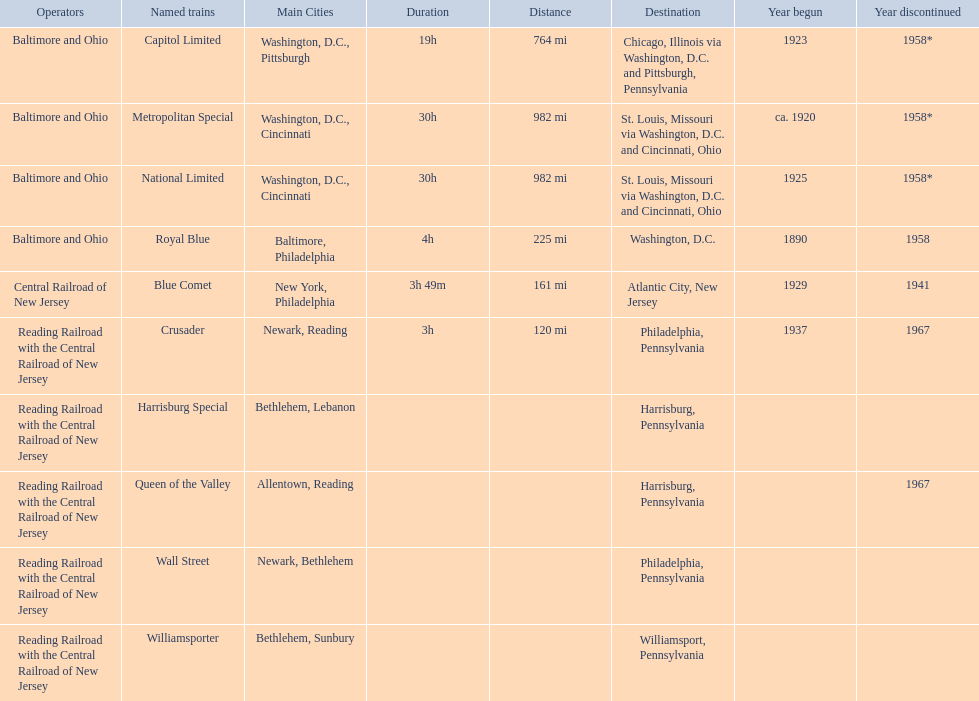What were all of the destinations? Chicago, Illinois via Washington, D.C. and Pittsburgh, Pennsylvania, St. Louis, Missouri via Washington, D.C. and Cincinnati, Ohio, St. Louis, Missouri via Washington, D.C. and Cincinnati, Ohio, Washington, D.C., Atlantic City, New Jersey, Philadelphia, Pennsylvania, Harrisburg, Pennsylvania, Harrisburg, Pennsylvania, Philadelphia, Pennsylvania, Williamsport, Pennsylvania. And what were the names of the trains? Capitol Limited, Metropolitan Special, National Limited, Royal Blue, Blue Comet, Crusader, Harrisburg Special, Queen of the Valley, Wall Street, Williamsporter. Of those, and along with wall street, which train ran to philadelphia, pennsylvania? Crusader. 